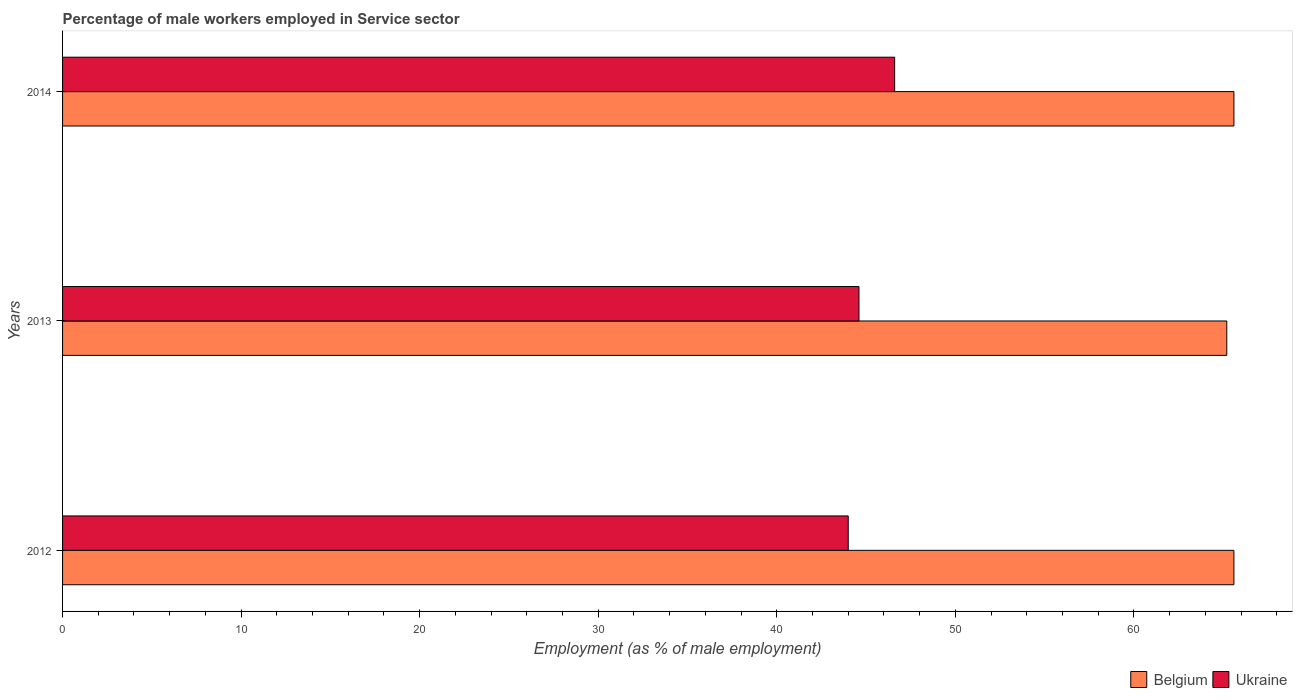How many different coloured bars are there?
Offer a very short reply. 2. Are the number of bars on each tick of the Y-axis equal?
Your answer should be very brief. Yes. How many bars are there on the 2nd tick from the bottom?
Your answer should be compact. 2. What is the label of the 3rd group of bars from the top?
Your answer should be compact. 2012. Across all years, what is the maximum percentage of male workers employed in Service sector in Ukraine?
Provide a short and direct response. 46.6. Across all years, what is the minimum percentage of male workers employed in Service sector in Ukraine?
Keep it short and to the point. 44. In which year was the percentage of male workers employed in Service sector in Belgium minimum?
Provide a succinct answer. 2013. What is the total percentage of male workers employed in Service sector in Ukraine in the graph?
Provide a succinct answer. 135.2. What is the difference between the percentage of male workers employed in Service sector in Belgium in 2012 and that in 2014?
Provide a short and direct response. 0. What is the difference between the percentage of male workers employed in Service sector in Belgium in 2014 and the percentage of male workers employed in Service sector in Ukraine in 2013?
Your answer should be compact. 21. What is the average percentage of male workers employed in Service sector in Ukraine per year?
Offer a very short reply. 45.07. In the year 2013, what is the difference between the percentage of male workers employed in Service sector in Ukraine and percentage of male workers employed in Service sector in Belgium?
Make the answer very short. -20.6. In how many years, is the percentage of male workers employed in Service sector in Belgium greater than 44 %?
Your response must be concise. 3. What is the ratio of the percentage of male workers employed in Service sector in Ukraine in 2013 to that in 2014?
Your answer should be very brief. 0.96. Is the difference between the percentage of male workers employed in Service sector in Ukraine in 2013 and 2014 greater than the difference between the percentage of male workers employed in Service sector in Belgium in 2013 and 2014?
Your answer should be very brief. No. What is the difference between the highest and the lowest percentage of male workers employed in Service sector in Belgium?
Your answer should be very brief. 0.4. In how many years, is the percentage of male workers employed in Service sector in Belgium greater than the average percentage of male workers employed in Service sector in Belgium taken over all years?
Ensure brevity in your answer.  2. What does the 1st bar from the top in 2013 represents?
Give a very brief answer. Ukraine. What does the 2nd bar from the bottom in 2014 represents?
Offer a very short reply. Ukraine. How many bars are there?
Your response must be concise. 6. Are all the bars in the graph horizontal?
Offer a terse response. Yes. How many years are there in the graph?
Ensure brevity in your answer.  3. Are the values on the major ticks of X-axis written in scientific E-notation?
Make the answer very short. No. Does the graph contain grids?
Offer a terse response. No. How are the legend labels stacked?
Your answer should be compact. Horizontal. What is the title of the graph?
Provide a short and direct response. Percentage of male workers employed in Service sector. Does "Brunei Darussalam" appear as one of the legend labels in the graph?
Your response must be concise. No. What is the label or title of the X-axis?
Provide a short and direct response. Employment (as % of male employment). What is the label or title of the Y-axis?
Your answer should be compact. Years. What is the Employment (as % of male employment) of Belgium in 2012?
Make the answer very short. 65.6. What is the Employment (as % of male employment) in Belgium in 2013?
Make the answer very short. 65.2. What is the Employment (as % of male employment) in Ukraine in 2013?
Offer a very short reply. 44.6. What is the Employment (as % of male employment) of Belgium in 2014?
Your answer should be very brief. 65.6. What is the Employment (as % of male employment) in Ukraine in 2014?
Ensure brevity in your answer.  46.6. Across all years, what is the maximum Employment (as % of male employment) in Belgium?
Your answer should be compact. 65.6. Across all years, what is the maximum Employment (as % of male employment) in Ukraine?
Your answer should be compact. 46.6. Across all years, what is the minimum Employment (as % of male employment) of Belgium?
Give a very brief answer. 65.2. Across all years, what is the minimum Employment (as % of male employment) of Ukraine?
Your answer should be very brief. 44. What is the total Employment (as % of male employment) in Belgium in the graph?
Your response must be concise. 196.4. What is the total Employment (as % of male employment) of Ukraine in the graph?
Keep it short and to the point. 135.2. What is the difference between the Employment (as % of male employment) of Belgium in 2012 and that in 2013?
Provide a short and direct response. 0.4. What is the difference between the Employment (as % of male employment) of Belgium in 2012 and that in 2014?
Your response must be concise. 0. What is the difference between the Employment (as % of male employment) in Belgium in 2013 and that in 2014?
Offer a terse response. -0.4. What is the difference between the Employment (as % of male employment) of Ukraine in 2013 and that in 2014?
Provide a short and direct response. -2. What is the average Employment (as % of male employment) in Belgium per year?
Your answer should be compact. 65.47. What is the average Employment (as % of male employment) in Ukraine per year?
Your answer should be very brief. 45.07. In the year 2012, what is the difference between the Employment (as % of male employment) of Belgium and Employment (as % of male employment) of Ukraine?
Your answer should be compact. 21.6. In the year 2013, what is the difference between the Employment (as % of male employment) of Belgium and Employment (as % of male employment) of Ukraine?
Ensure brevity in your answer.  20.6. What is the ratio of the Employment (as % of male employment) of Ukraine in 2012 to that in 2013?
Keep it short and to the point. 0.99. What is the ratio of the Employment (as % of male employment) of Belgium in 2012 to that in 2014?
Provide a succinct answer. 1. What is the ratio of the Employment (as % of male employment) of Ukraine in 2012 to that in 2014?
Give a very brief answer. 0.94. What is the ratio of the Employment (as % of male employment) of Belgium in 2013 to that in 2014?
Give a very brief answer. 0.99. What is the ratio of the Employment (as % of male employment) of Ukraine in 2013 to that in 2014?
Provide a succinct answer. 0.96. What is the difference between the highest and the second highest Employment (as % of male employment) of Belgium?
Give a very brief answer. 0. 